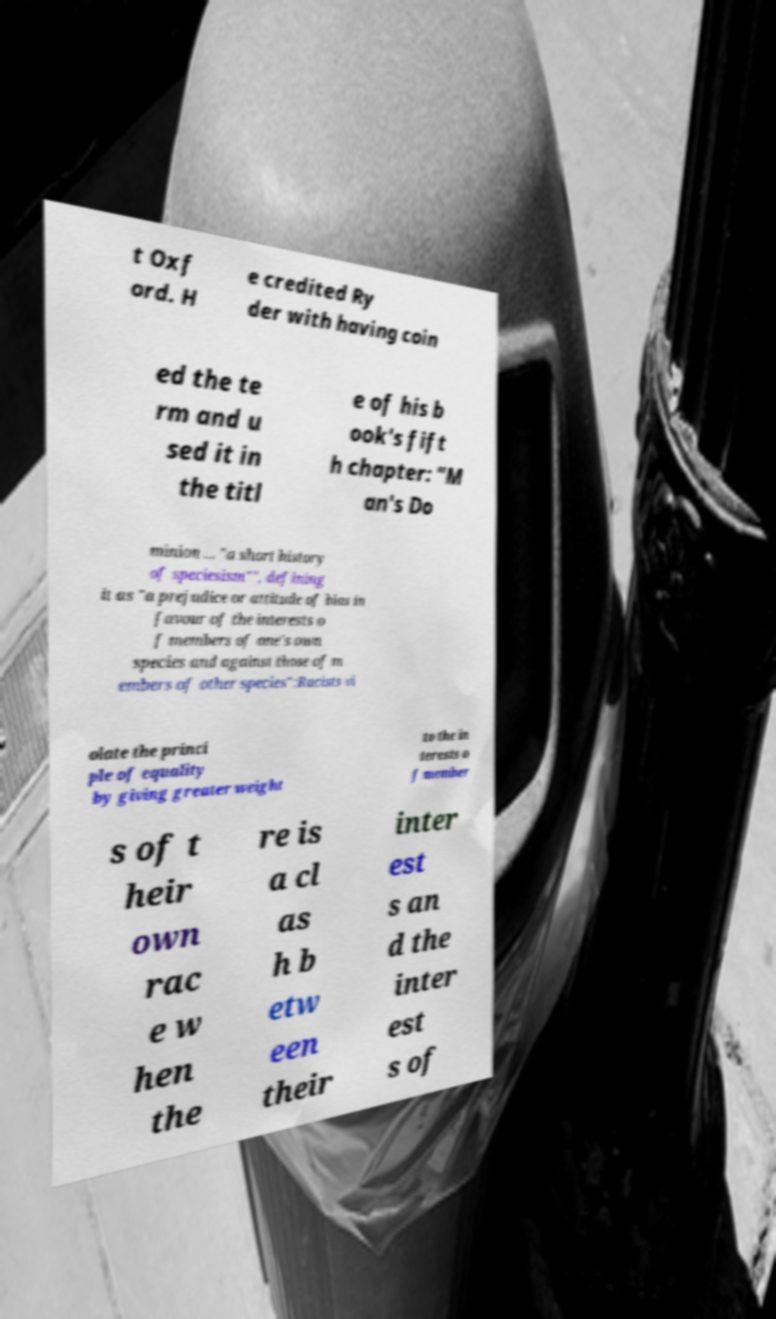For documentation purposes, I need the text within this image transcribed. Could you provide that? t Oxf ord. H e credited Ry der with having coin ed the te rm and u sed it in the titl e of his b ook's fift h chapter: "M an's Do minion ... "a short history of speciesism"", defining it as "a prejudice or attitude of bias in favour of the interests o f members of one's own species and against those of m embers of other species":Racists vi olate the princi ple of equality by giving greater weight to the in terests o f member s of t heir own rac e w hen the re is a cl as h b etw een their inter est s an d the inter est s of 